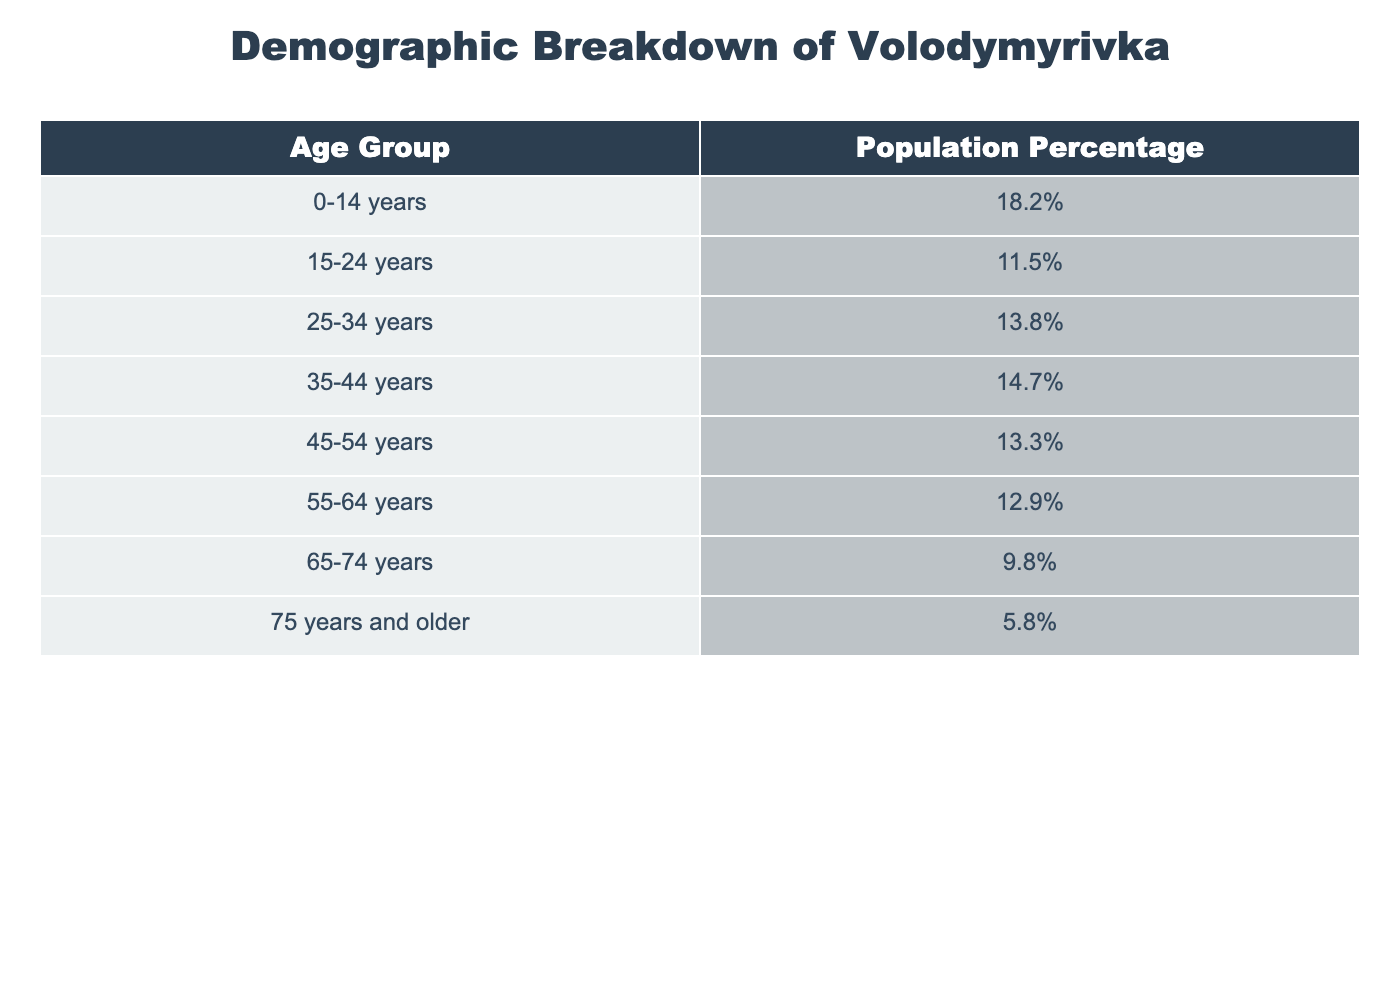What percentage of the population is aged 0-14 years? From the table, the population percentage for the age group 0-14 years is clearly listed as 18.2%.
Answer: 18.2% What is the population percentage of the age group 65-74 years? The table directly shows the population percentage for the age group 65-74 years as 9.8%.
Answer: 9.8% Which age group has the highest population percentage? By comparing all the percentages in the table, the age group 35-44 years has the highest population percentage at 14.7%.
Answer: 35-44 years How many percentage points more does the 25-34 age group have compared to the 75 years and older group? The population percentage for the 25-34 age group is 13.8%, and for the 75 years and older group, it is 5.8%. The difference is 13.8% - 5.8% = 8.0 percentage points.
Answer: 8.0 percentage points What is the total population percentage for all age groups listed? The total population percentage for all age groups should sum to 100%, as these are discrete groups covering the entire population.
Answer: 100% Is it true that more than half of the population is aged 0-14 years or 15-24 years combined? The combined population percentage for ages 0-14 years and 15-24 years is 18.2% + 11.5% = 29.7%, which is less than half of 100%.
Answer: No What percentage of the population is aged 55 years and older? To find this percentage, sum the percentages of the age groups 55-64 years, 65-74 years, and 75 years and older: 12.9% + 9.8% + 5.8% = 28.5%.
Answer: 28.5% How does the population percentage of the 45-54 age group compare to that of the 15-24 age group? The 45-54 age group has a population percentage of 13.3%, while the 15-24 age group has 11.5%. The 45-54 age group is 1.8 percentage points higher.
Answer: 1.8 percentage points higher Which age group has a population percentage closest to the average of all age groups? The average can be calculated by summing all percentages (100%) and dividing by the number of groups (8), resulting in 12.5%. The age group that is closest is 55-64 years with 12.9%.
Answer: 55-64 years What percentage of the population is aged between 15 and 44 years? Adding the percentages for age groups 15-24, 25-34, and 35-44 gives us 11.5% + 13.8% + 14.7% = 40.0%.
Answer: 40.0% 